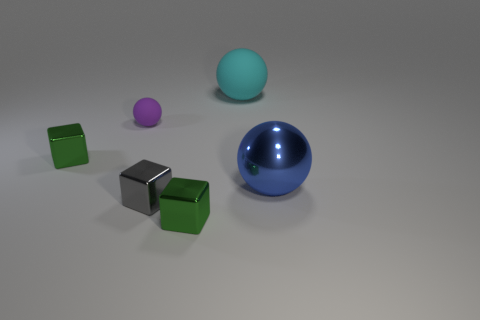Is there anything else that has the same size as the metallic ball?
Give a very brief answer. Yes. There is a tiny rubber object; is its color the same as the sphere that is on the right side of the big cyan rubber ball?
Your answer should be compact. No. Are there any tiny cubes that have the same color as the tiny rubber thing?
Offer a very short reply. No. Is the material of the tiny purple sphere the same as the small cube to the left of the purple object?
Give a very brief answer. No. How many large things are either purple objects or metal things?
Offer a very short reply. 1. Are there fewer green shiny blocks than small red cylinders?
Your answer should be compact. No. There is a gray object in front of the big blue thing; does it have the same size as the green cube that is behind the blue object?
Offer a terse response. Yes. How many gray objects are small metallic things or large matte cylinders?
Your answer should be compact. 1. Is the number of large blue balls greater than the number of small brown shiny cubes?
Ensure brevity in your answer.  Yes. Is the big metal thing the same color as the tiny rubber object?
Keep it short and to the point. No. 